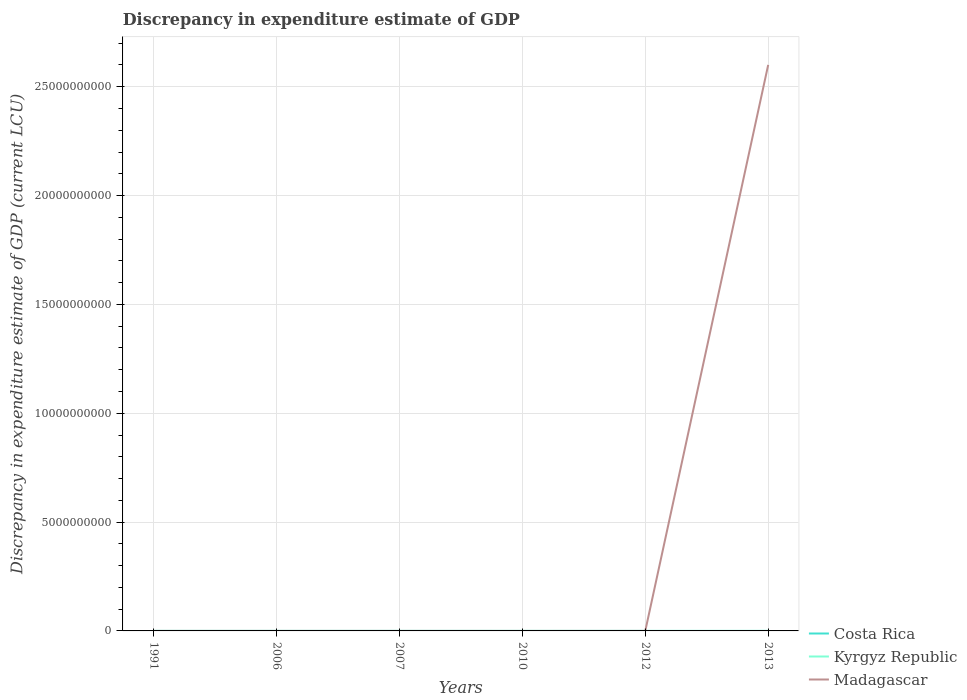How many different coloured lines are there?
Your answer should be very brief. 3. Is the number of lines equal to the number of legend labels?
Provide a succinct answer. No. Across all years, what is the maximum discrepancy in expenditure estimate of GDP in Kyrgyz Republic?
Your answer should be very brief. 0. What is the total discrepancy in expenditure estimate of GDP in Madagascar in the graph?
Ensure brevity in your answer.  -0. What is the difference between the highest and the second highest discrepancy in expenditure estimate of GDP in Costa Rica?
Ensure brevity in your answer.  2.00e+05. What is the difference between the highest and the lowest discrepancy in expenditure estimate of GDP in Costa Rica?
Provide a short and direct response. 3. How many lines are there?
Make the answer very short. 3. What is the difference between two consecutive major ticks on the Y-axis?
Make the answer very short. 5.00e+09. How are the legend labels stacked?
Give a very brief answer. Vertical. What is the title of the graph?
Provide a short and direct response. Discrepancy in expenditure estimate of GDP. What is the label or title of the Y-axis?
Keep it short and to the point. Discrepancy in expenditure estimate of GDP (current LCU). What is the Discrepancy in expenditure estimate of GDP (current LCU) in Costa Rica in 1991?
Make the answer very short. 1.00e+05. What is the Discrepancy in expenditure estimate of GDP (current LCU) of Kyrgyz Republic in 1991?
Give a very brief answer. 1.90e+04. What is the Discrepancy in expenditure estimate of GDP (current LCU) of Madagascar in 1991?
Give a very brief answer. 100. What is the Discrepancy in expenditure estimate of GDP (current LCU) of Costa Rica in 2006?
Provide a succinct answer. 2.00e+05. What is the Discrepancy in expenditure estimate of GDP (current LCU) of Kyrgyz Republic in 2006?
Make the answer very short. 1.5e-5. What is the Discrepancy in expenditure estimate of GDP (current LCU) in Madagascar in 2006?
Make the answer very short. 4.08e+04. What is the Discrepancy in expenditure estimate of GDP (current LCU) in Madagascar in 2007?
Keep it short and to the point. 3400. What is the Discrepancy in expenditure estimate of GDP (current LCU) of Kyrgyz Republic in 2010?
Provide a short and direct response. 2.800000000000001e-5. What is the Discrepancy in expenditure estimate of GDP (current LCU) of Madagascar in 2010?
Provide a succinct answer. 0. What is the Discrepancy in expenditure estimate of GDP (current LCU) in Costa Rica in 2012?
Your answer should be compact. 1.00e+05. What is the Discrepancy in expenditure estimate of GDP (current LCU) in Kyrgyz Republic in 2012?
Your response must be concise. 0. What is the Discrepancy in expenditure estimate of GDP (current LCU) of Madagascar in 2012?
Give a very brief answer. 100. What is the Discrepancy in expenditure estimate of GDP (current LCU) in Kyrgyz Republic in 2013?
Keep it short and to the point. 8e-6. What is the Discrepancy in expenditure estimate of GDP (current LCU) of Madagascar in 2013?
Ensure brevity in your answer.  2.60e+1. Across all years, what is the maximum Discrepancy in expenditure estimate of GDP (current LCU) of Costa Rica?
Ensure brevity in your answer.  2.00e+05. Across all years, what is the maximum Discrepancy in expenditure estimate of GDP (current LCU) in Kyrgyz Republic?
Provide a short and direct response. 1.90e+04. Across all years, what is the maximum Discrepancy in expenditure estimate of GDP (current LCU) in Madagascar?
Your answer should be compact. 2.60e+1. Across all years, what is the minimum Discrepancy in expenditure estimate of GDP (current LCU) of Kyrgyz Republic?
Give a very brief answer. 0. What is the total Discrepancy in expenditure estimate of GDP (current LCU) in Kyrgyz Republic in the graph?
Your answer should be very brief. 1.90e+04. What is the total Discrepancy in expenditure estimate of GDP (current LCU) of Madagascar in the graph?
Your answer should be very brief. 2.60e+1. What is the difference between the Discrepancy in expenditure estimate of GDP (current LCU) of Kyrgyz Republic in 1991 and that in 2006?
Your answer should be compact. 1.90e+04. What is the difference between the Discrepancy in expenditure estimate of GDP (current LCU) of Madagascar in 1991 and that in 2006?
Your response must be concise. -4.07e+04. What is the difference between the Discrepancy in expenditure estimate of GDP (current LCU) of Madagascar in 1991 and that in 2007?
Your answer should be compact. -3300. What is the difference between the Discrepancy in expenditure estimate of GDP (current LCU) in Kyrgyz Republic in 1991 and that in 2010?
Offer a terse response. 1.90e+04. What is the difference between the Discrepancy in expenditure estimate of GDP (current LCU) of Costa Rica in 1991 and that in 2012?
Keep it short and to the point. 0. What is the difference between the Discrepancy in expenditure estimate of GDP (current LCU) in Madagascar in 1991 and that in 2012?
Provide a succinct answer. -0. What is the difference between the Discrepancy in expenditure estimate of GDP (current LCU) in Kyrgyz Republic in 1991 and that in 2013?
Offer a very short reply. 1.90e+04. What is the difference between the Discrepancy in expenditure estimate of GDP (current LCU) of Madagascar in 1991 and that in 2013?
Make the answer very short. -2.60e+1. What is the difference between the Discrepancy in expenditure estimate of GDP (current LCU) of Madagascar in 2006 and that in 2007?
Make the answer very short. 3.74e+04. What is the difference between the Discrepancy in expenditure estimate of GDP (current LCU) in Kyrgyz Republic in 2006 and that in 2010?
Provide a succinct answer. -0. What is the difference between the Discrepancy in expenditure estimate of GDP (current LCU) of Madagascar in 2006 and that in 2012?
Your answer should be very brief. 4.07e+04. What is the difference between the Discrepancy in expenditure estimate of GDP (current LCU) of Madagascar in 2006 and that in 2013?
Your answer should be compact. -2.60e+1. What is the difference between the Discrepancy in expenditure estimate of GDP (current LCU) in Madagascar in 2007 and that in 2012?
Your answer should be compact. 3300. What is the difference between the Discrepancy in expenditure estimate of GDP (current LCU) in Madagascar in 2007 and that in 2013?
Your response must be concise. -2.60e+1. What is the difference between the Discrepancy in expenditure estimate of GDP (current LCU) of Madagascar in 2012 and that in 2013?
Your answer should be compact. -2.60e+1. What is the difference between the Discrepancy in expenditure estimate of GDP (current LCU) of Costa Rica in 1991 and the Discrepancy in expenditure estimate of GDP (current LCU) of Madagascar in 2006?
Your response must be concise. 5.92e+04. What is the difference between the Discrepancy in expenditure estimate of GDP (current LCU) of Kyrgyz Republic in 1991 and the Discrepancy in expenditure estimate of GDP (current LCU) of Madagascar in 2006?
Give a very brief answer. -2.18e+04. What is the difference between the Discrepancy in expenditure estimate of GDP (current LCU) of Costa Rica in 1991 and the Discrepancy in expenditure estimate of GDP (current LCU) of Madagascar in 2007?
Make the answer very short. 9.66e+04. What is the difference between the Discrepancy in expenditure estimate of GDP (current LCU) of Kyrgyz Republic in 1991 and the Discrepancy in expenditure estimate of GDP (current LCU) of Madagascar in 2007?
Your response must be concise. 1.56e+04. What is the difference between the Discrepancy in expenditure estimate of GDP (current LCU) of Costa Rica in 1991 and the Discrepancy in expenditure estimate of GDP (current LCU) of Madagascar in 2012?
Keep it short and to the point. 9.99e+04. What is the difference between the Discrepancy in expenditure estimate of GDP (current LCU) of Kyrgyz Republic in 1991 and the Discrepancy in expenditure estimate of GDP (current LCU) of Madagascar in 2012?
Make the answer very short. 1.89e+04. What is the difference between the Discrepancy in expenditure estimate of GDP (current LCU) of Costa Rica in 1991 and the Discrepancy in expenditure estimate of GDP (current LCU) of Kyrgyz Republic in 2013?
Provide a succinct answer. 1.00e+05. What is the difference between the Discrepancy in expenditure estimate of GDP (current LCU) in Costa Rica in 1991 and the Discrepancy in expenditure estimate of GDP (current LCU) in Madagascar in 2013?
Ensure brevity in your answer.  -2.60e+1. What is the difference between the Discrepancy in expenditure estimate of GDP (current LCU) of Kyrgyz Republic in 1991 and the Discrepancy in expenditure estimate of GDP (current LCU) of Madagascar in 2013?
Offer a very short reply. -2.60e+1. What is the difference between the Discrepancy in expenditure estimate of GDP (current LCU) of Costa Rica in 2006 and the Discrepancy in expenditure estimate of GDP (current LCU) of Madagascar in 2007?
Your answer should be compact. 1.97e+05. What is the difference between the Discrepancy in expenditure estimate of GDP (current LCU) in Kyrgyz Republic in 2006 and the Discrepancy in expenditure estimate of GDP (current LCU) in Madagascar in 2007?
Provide a short and direct response. -3400. What is the difference between the Discrepancy in expenditure estimate of GDP (current LCU) in Costa Rica in 2006 and the Discrepancy in expenditure estimate of GDP (current LCU) in Kyrgyz Republic in 2010?
Offer a very short reply. 2.00e+05. What is the difference between the Discrepancy in expenditure estimate of GDP (current LCU) of Costa Rica in 2006 and the Discrepancy in expenditure estimate of GDP (current LCU) of Madagascar in 2012?
Your answer should be very brief. 2.00e+05. What is the difference between the Discrepancy in expenditure estimate of GDP (current LCU) of Kyrgyz Republic in 2006 and the Discrepancy in expenditure estimate of GDP (current LCU) of Madagascar in 2012?
Your answer should be very brief. -100. What is the difference between the Discrepancy in expenditure estimate of GDP (current LCU) of Costa Rica in 2006 and the Discrepancy in expenditure estimate of GDP (current LCU) of Madagascar in 2013?
Ensure brevity in your answer.  -2.60e+1. What is the difference between the Discrepancy in expenditure estimate of GDP (current LCU) of Kyrgyz Republic in 2006 and the Discrepancy in expenditure estimate of GDP (current LCU) of Madagascar in 2013?
Make the answer very short. -2.60e+1. What is the difference between the Discrepancy in expenditure estimate of GDP (current LCU) in Kyrgyz Republic in 2010 and the Discrepancy in expenditure estimate of GDP (current LCU) in Madagascar in 2012?
Your response must be concise. -100. What is the difference between the Discrepancy in expenditure estimate of GDP (current LCU) of Kyrgyz Republic in 2010 and the Discrepancy in expenditure estimate of GDP (current LCU) of Madagascar in 2013?
Provide a succinct answer. -2.60e+1. What is the difference between the Discrepancy in expenditure estimate of GDP (current LCU) in Costa Rica in 2012 and the Discrepancy in expenditure estimate of GDP (current LCU) in Kyrgyz Republic in 2013?
Offer a terse response. 1.00e+05. What is the difference between the Discrepancy in expenditure estimate of GDP (current LCU) in Costa Rica in 2012 and the Discrepancy in expenditure estimate of GDP (current LCU) in Madagascar in 2013?
Offer a very short reply. -2.60e+1. What is the average Discrepancy in expenditure estimate of GDP (current LCU) in Costa Rica per year?
Keep it short and to the point. 6.67e+04. What is the average Discrepancy in expenditure estimate of GDP (current LCU) in Kyrgyz Republic per year?
Your response must be concise. 3166.67. What is the average Discrepancy in expenditure estimate of GDP (current LCU) of Madagascar per year?
Ensure brevity in your answer.  4.33e+09. In the year 1991, what is the difference between the Discrepancy in expenditure estimate of GDP (current LCU) of Costa Rica and Discrepancy in expenditure estimate of GDP (current LCU) of Kyrgyz Republic?
Your answer should be very brief. 8.10e+04. In the year 1991, what is the difference between the Discrepancy in expenditure estimate of GDP (current LCU) in Costa Rica and Discrepancy in expenditure estimate of GDP (current LCU) in Madagascar?
Provide a succinct answer. 9.99e+04. In the year 1991, what is the difference between the Discrepancy in expenditure estimate of GDP (current LCU) in Kyrgyz Republic and Discrepancy in expenditure estimate of GDP (current LCU) in Madagascar?
Keep it short and to the point. 1.89e+04. In the year 2006, what is the difference between the Discrepancy in expenditure estimate of GDP (current LCU) in Costa Rica and Discrepancy in expenditure estimate of GDP (current LCU) in Kyrgyz Republic?
Offer a terse response. 2.00e+05. In the year 2006, what is the difference between the Discrepancy in expenditure estimate of GDP (current LCU) of Costa Rica and Discrepancy in expenditure estimate of GDP (current LCU) of Madagascar?
Give a very brief answer. 1.59e+05. In the year 2006, what is the difference between the Discrepancy in expenditure estimate of GDP (current LCU) of Kyrgyz Republic and Discrepancy in expenditure estimate of GDP (current LCU) of Madagascar?
Provide a short and direct response. -4.08e+04. In the year 2012, what is the difference between the Discrepancy in expenditure estimate of GDP (current LCU) in Costa Rica and Discrepancy in expenditure estimate of GDP (current LCU) in Madagascar?
Offer a terse response. 9.99e+04. In the year 2013, what is the difference between the Discrepancy in expenditure estimate of GDP (current LCU) in Kyrgyz Republic and Discrepancy in expenditure estimate of GDP (current LCU) in Madagascar?
Ensure brevity in your answer.  -2.60e+1. What is the ratio of the Discrepancy in expenditure estimate of GDP (current LCU) in Kyrgyz Republic in 1991 to that in 2006?
Make the answer very short. 1.27e+09. What is the ratio of the Discrepancy in expenditure estimate of GDP (current LCU) of Madagascar in 1991 to that in 2006?
Make the answer very short. 0. What is the ratio of the Discrepancy in expenditure estimate of GDP (current LCU) in Madagascar in 1991 to that in 2007?
Make the answer very short. 0.03. What is the ratio of the Discrepancy in expenditure estimate of GDP (current LCU) of Kyrgyz Republic in 1991 to that in 2010?
Your answer should be very brief. 6.79e+08. What is the ratio of the Discrepancy in expenditure estimate of GDP (current LCU) of Kyrgyz Republic in 1991 to that in 2013?
Offer a terse response. 2.38e+09. What is the ratio of the Discrepancy in expenditure estimate of GDP (current LCU) in Madagascar in 2006 to that in 2007?
Keep it short and to the point. 12. What is the ratio of the Discrepancy in expenditure estimate of GDP (current LCU) of Kyrgyz Republic in 2006 to that in 2010?
Offer a terse response. 0.54. What is the ratio of the Discrepancy in expenditure estimate of GDP (current LCU) in Costa Rica in 2006 to that in 2012?
Offer a very short reply. 2. What is the ratio of the Discrepancy in expenditure estimate of GDP (current LCU) in Madagascar in 2006 to that in 2012?
Provide a succinct answer. 408. What is the ratio of the Discrepancy in expenditure estimate of GDP (current LCU) in Kyrgyz Republic in 2006 to that in 2013?
Make the answer very short. 1.88. What is the ratio of the Discrepancy in expenditure estimate of GDP (current LCU) of Madagascar in 2006 to that in 2013?
Your answer should be compact. 0. What is the ratio of the Discrepancy in expenditure estimate of GDP (current LCU) of Madagascar in 2007 to that in 2012?
Provide a short and direct response. 34. What is the ratio of the Discrepancy in expenditure estimate of GDP (current LCU) of Kyrgyz Republic in 2010 to that in 2013?
Give a very brief answer. 3.5. What is the ratio of the Discrepancy in expenditure estimate of GDP (current LCU) in Madagascar in 2012 to that in 2013?
Make the answer very short. 0. What is the difference between the highest and the second highest Discrepancy in expenditure estimate of GDP (current LCU) in Costa Rica?
Provide a short and direct response. 1.00e+05. What is the difference between the highest and the second highest Discrepancy in expenditure estimate of GDP (current LCU) in Kyrgyz Republic?
Your response must be concise. 1.90e+04. What is the difference between the highest and the second highest Discrepancy in expenditure estimate of GDP (current LCU) of Madagascar?
Make the answer very short. 2.60e+1. What is the difference between the highest and the lowest Discrepancy in expenditure estimate of GDP (current LCU) of Costa Rica?
Provide a short and direct response. 2.00e+05. What is the difference between the highest and the lowest Discrepancy in expenditure estimate of GDP (current LCU) in Kyrgyz Republic?
Keep it short and to the point. 1.90e+04. What is the difference between the highest and the lowest Discrepancy in expenditure estimate of GDP (current LCU) in Madagascar?
Provide a succinct answer. 2.60e+1. 